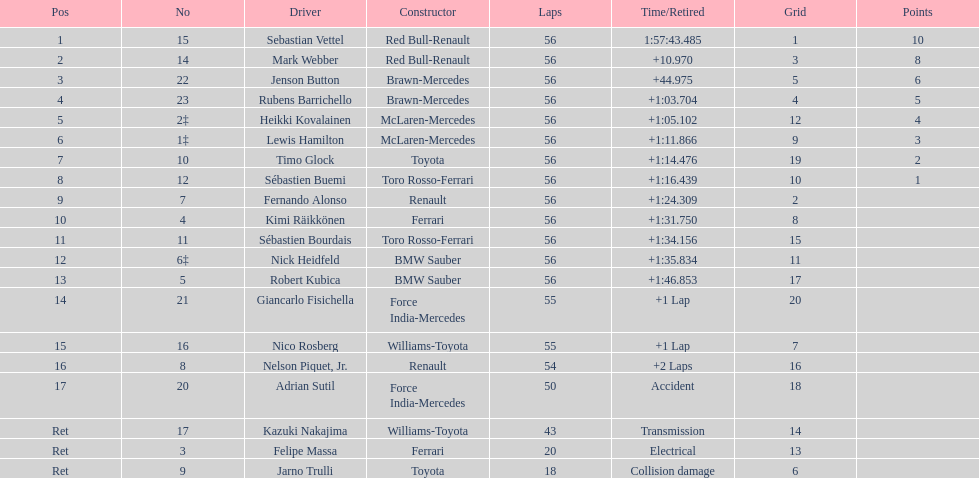Which driver is the only driver who retired because of collision damage? Jarno Trulli. 